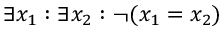Convert formula to latex. <formula><loc_0><loc_0><loc_500><loc_500>\exists x _ { 1 } \colon \exists x _ { 2 } \colon \ln o t ( x _ { 1 } = x _ { 2 } )</formula> 